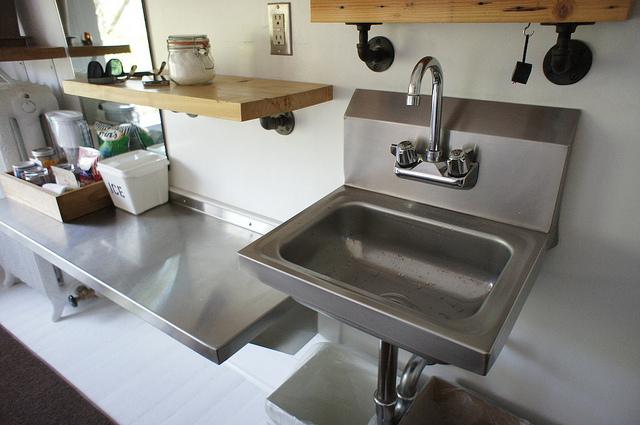Where are the sunglasses?
Keep it brief. Shelf. Is the water turned on?
Give a very brief answer. No. What room is this?
Keep it brief. Kitchen. 